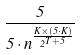<formula> <loc_0><loc_0><loc_500><loc_500>\frac { 5 } { 5 \cdot n ^ { \frac { K \times ( 5 \cdot K ) } { 2 ^ { T + 5 } } } }</formula> 